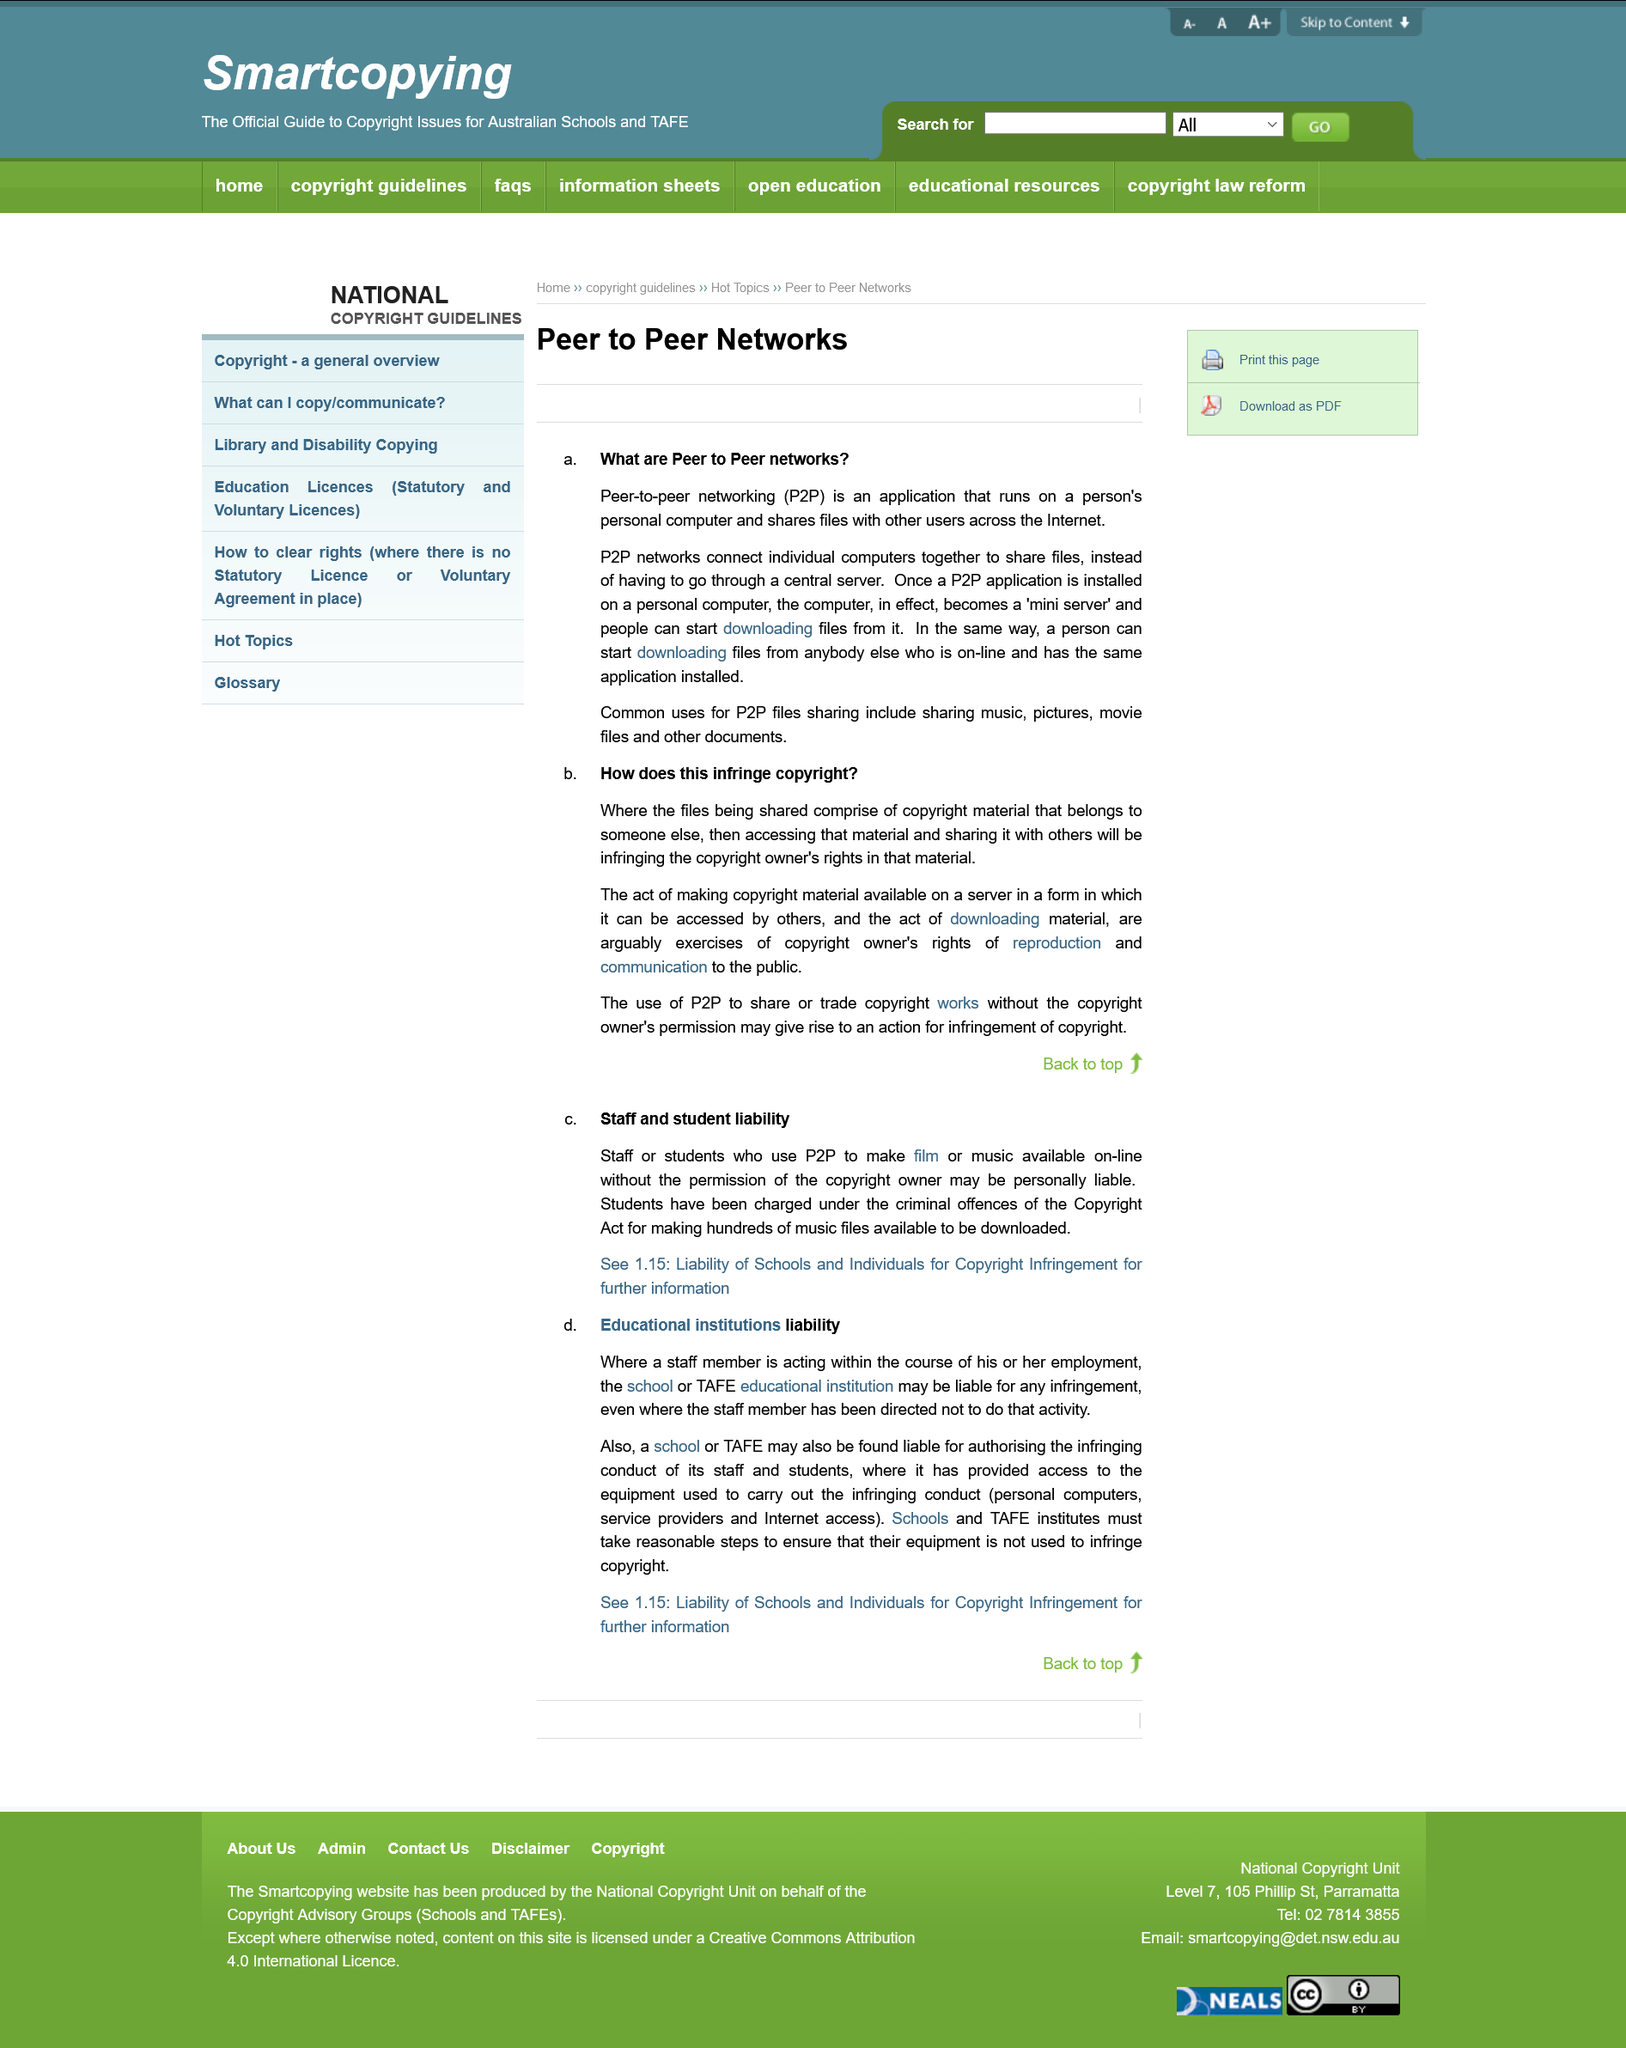Specify some key components in this picture. It is possible for the TAFE educational institution to be held liable for copyright infringement if a staff member uses P2P to make music available online without the copyright owner's permission. Peer-to-peer networking, commonly referred to as P2P, is a method of direct communication between two or more devices without the involvement of a central server or intermediary. Peer-to-peer (P2P) networks can connect computers together. The TAFE educational institution would remain liable if its staff infringe copyrights, even if the institution has directed its staff not to do so. Peer-to-peer networks are applications that run on personal computers and allow users to share files across the internet by connecting directly with other users rather than through a central server. 